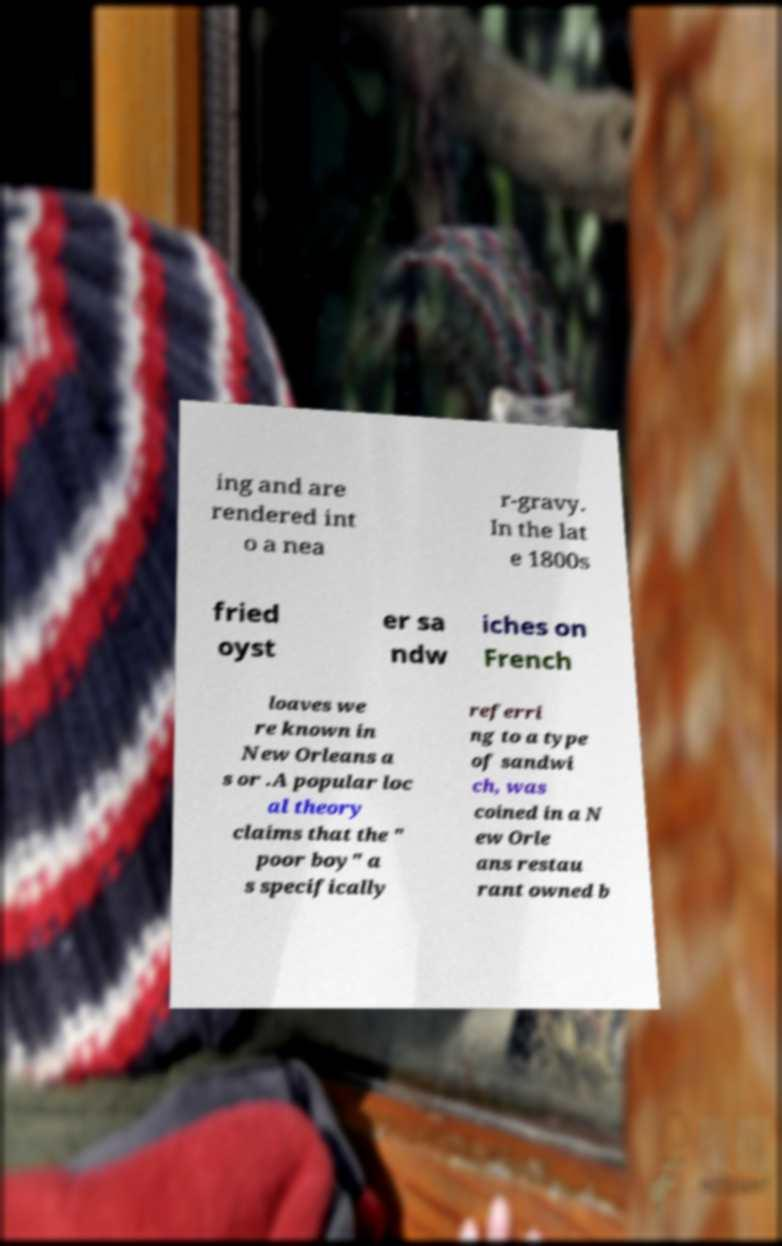Could you assist in decoding the text presented in this image and type it out clearly? ing and are rendered int o a nea r-gravy. In the lat e 1800s fried oyst er sa ndw iches on French loaves we re known in New Orleans a s or .A popular loc al theory claims that the " poor boy" a s specifically referri ng to a type of sandwi ch, was coined in a N ew Orle ans restau rant owned b 